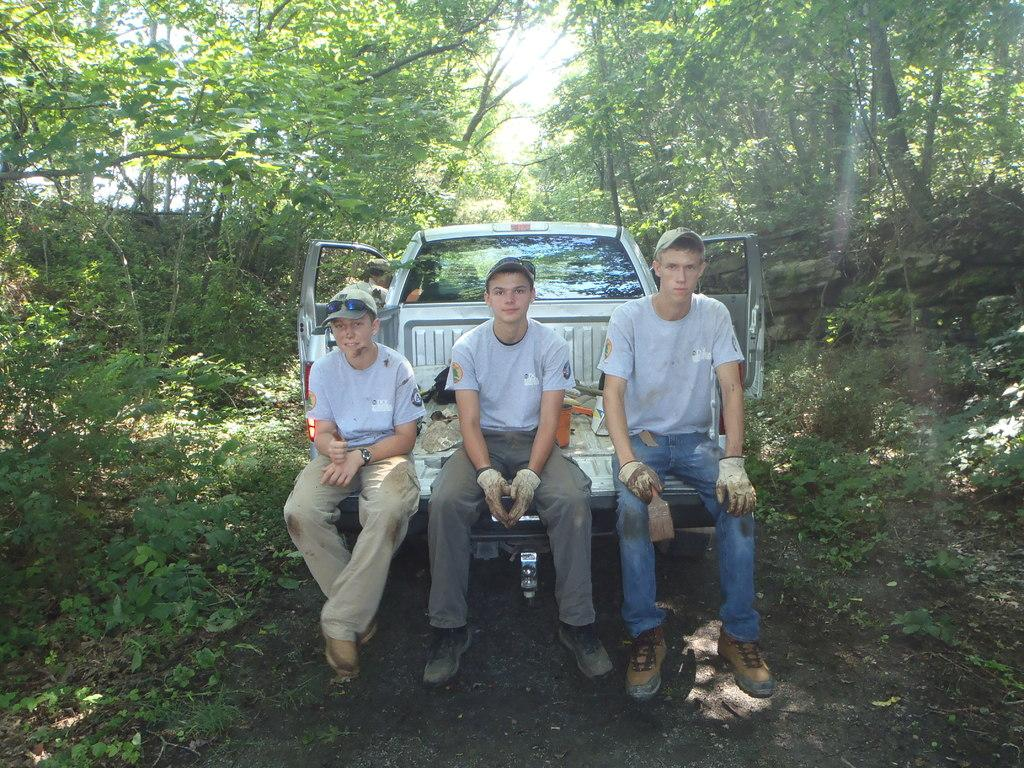How many people are in the image? There are three persons in the image. What are the persons doing in the image? The persons are sitting on vehicles. What can be seen behind the vehicles in the image? There are trees visible behind the vehicles. What is visible behind the trees in the image? The sky is visible behind the trees. What type of haircut does the tree have in the image? There is no haircut present in the image, as trees do not have hair. 